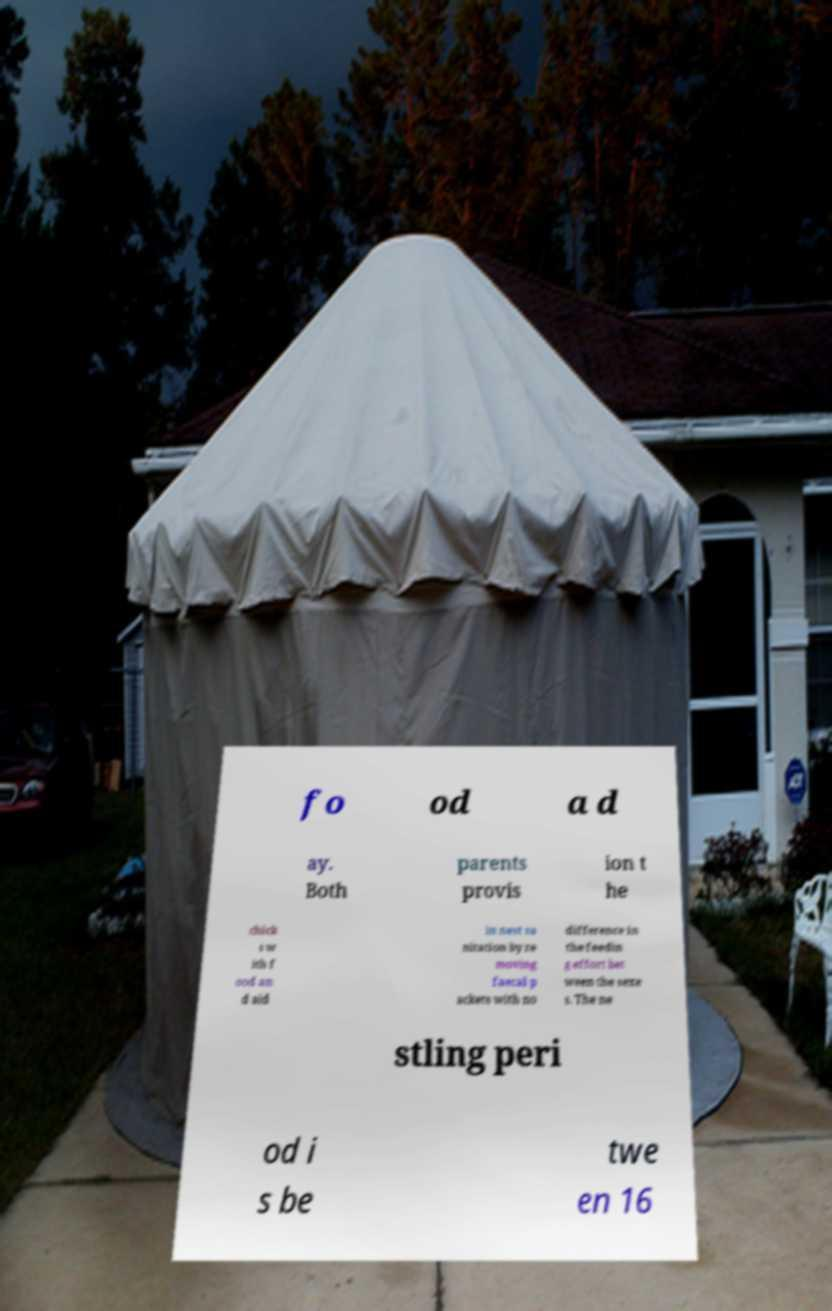Please read and relay the text visible in this image. What does it say? fo od a d ay. Both parents provis ion t he chick s w ith f ood an d aid in nest sa nitation by re moving faecal p ackets with no difference in the feedin g effort bet ween the sexe s. The ne stling peri od i s be twe en 16 